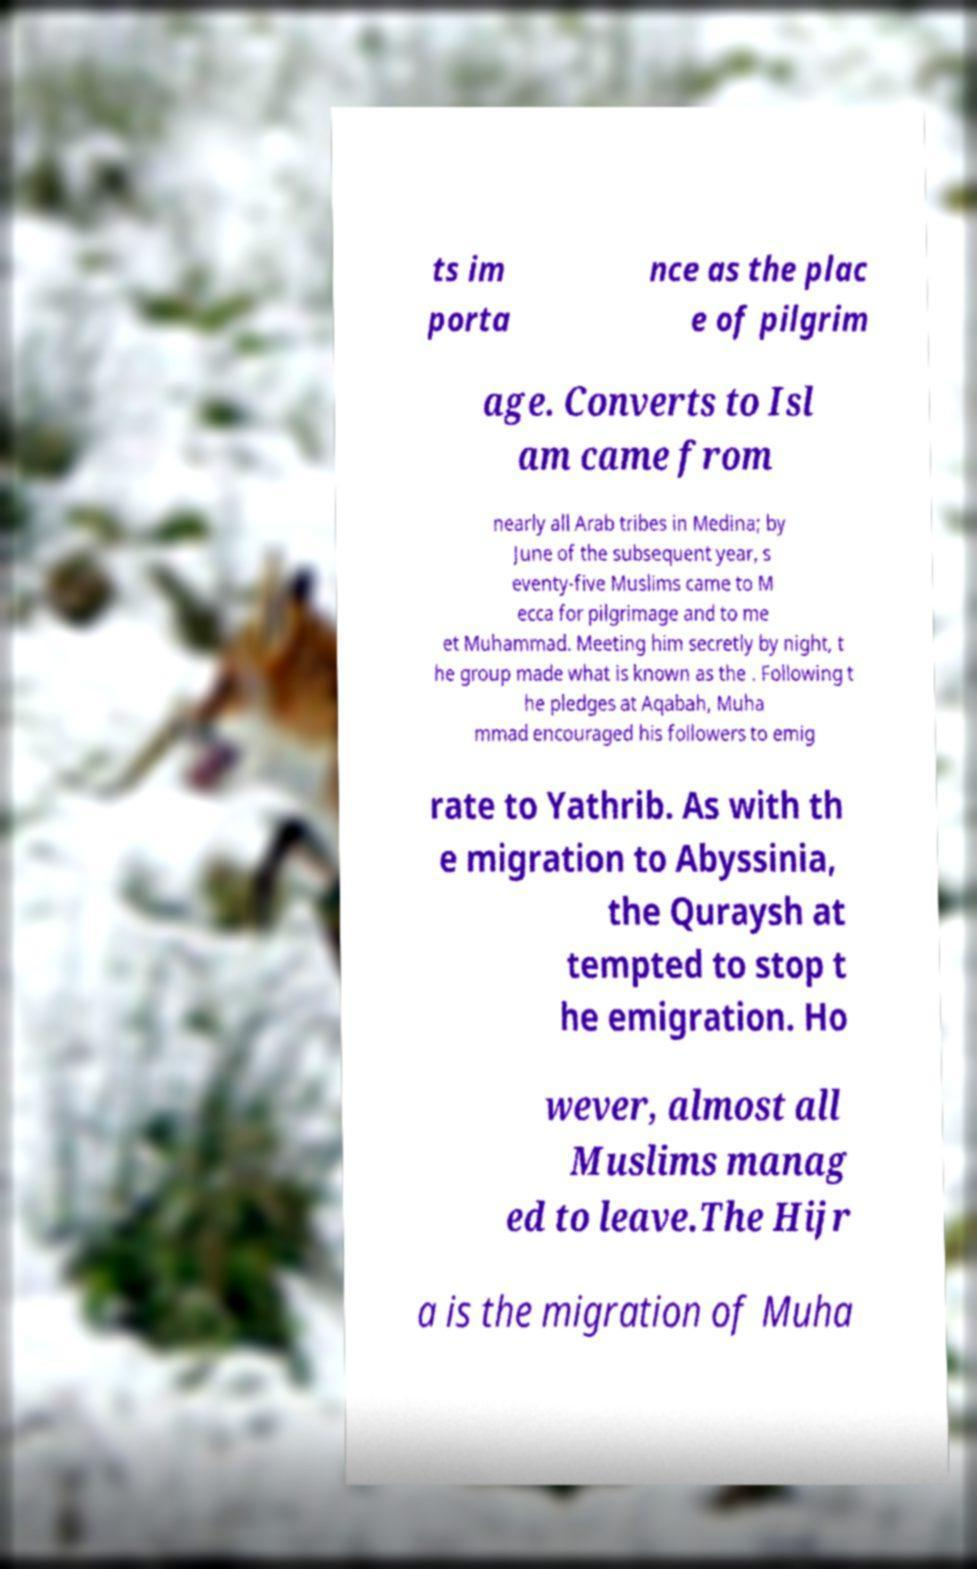Please identify and transcribe the text found in this image. ts im porta nce as the plac e of pilgrim age. Converts to Isl am came from nearly all Arab tribes in Medina; by June of the subsequent year, s eventy-five Muslims came to M ecca for pilgrimage and to me et Muhammad. Meeting him secretly by night, t he group made what is known as the . Following t he pledges at Aqabah, Muha mmad encouraged his followers to emig rate to Yathrib. As with th e migration to Abyssinia, the Quraysh at tempted to stop t he emigration. Ho wever, almost all Muslims manag ed to leave.The Hijr a is the migration of Muha 